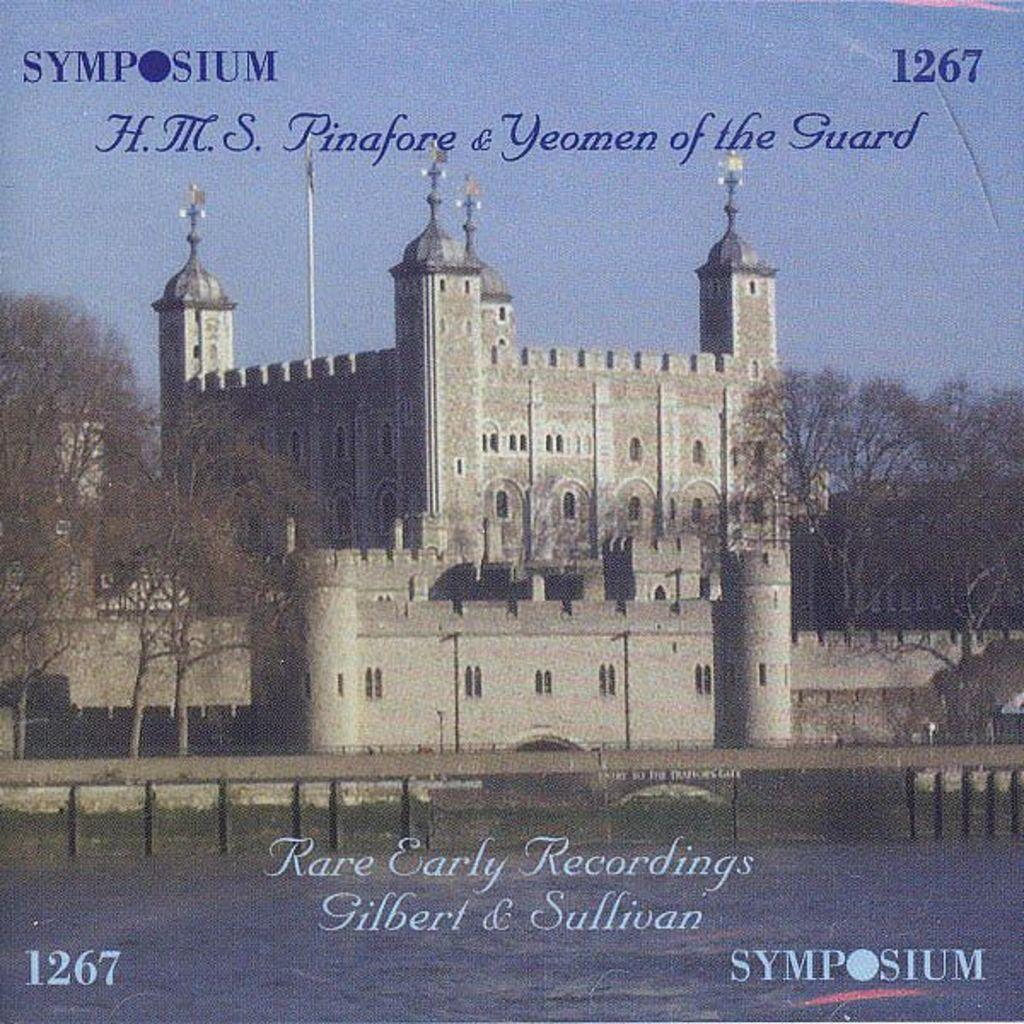What is the main element present in the image? There is water in the image. What structure can be seen crossing over the water? A: There is a bridge in the image. What type of man-made structures are visible in the image? There are buildings in the image. What type of vegetation can be seen in the image? There is grass and trees in the image. What else is visible in the image besides the water, bridge, buildings, grass, and trees? There is text visible in the image. What part of the natural environment is visible in the image? The sky is visible in the image. What type of underwear is being taught in the image? There is no teaching or underwear present in the image. What is the source of the shock in the image? There is no shock or any indication of a shocking event in the image. 